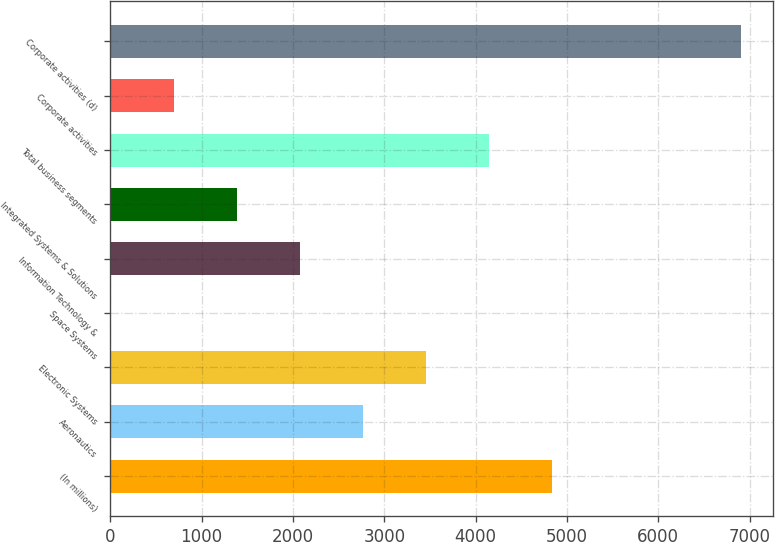<chart> <loc_0><loc_0><loc_500><loc_500><bar_chart><fcel>(In millions)<fcel>Aeronautics<fcel>Electronic Systems<fcel>Space Systems<fcel>Information Technology &<fcel>Integrated Systems & Solutions<fcel>Total business segments<fcel>Corporate activities<fcel>Corporate activities (d)<nl><fcel>4839<fcel>2769<fcel>3459<fcel>9<fcel>2079<fcel>1389<fcel>4149<fcel>699<fcel>6909<nl></chart> 